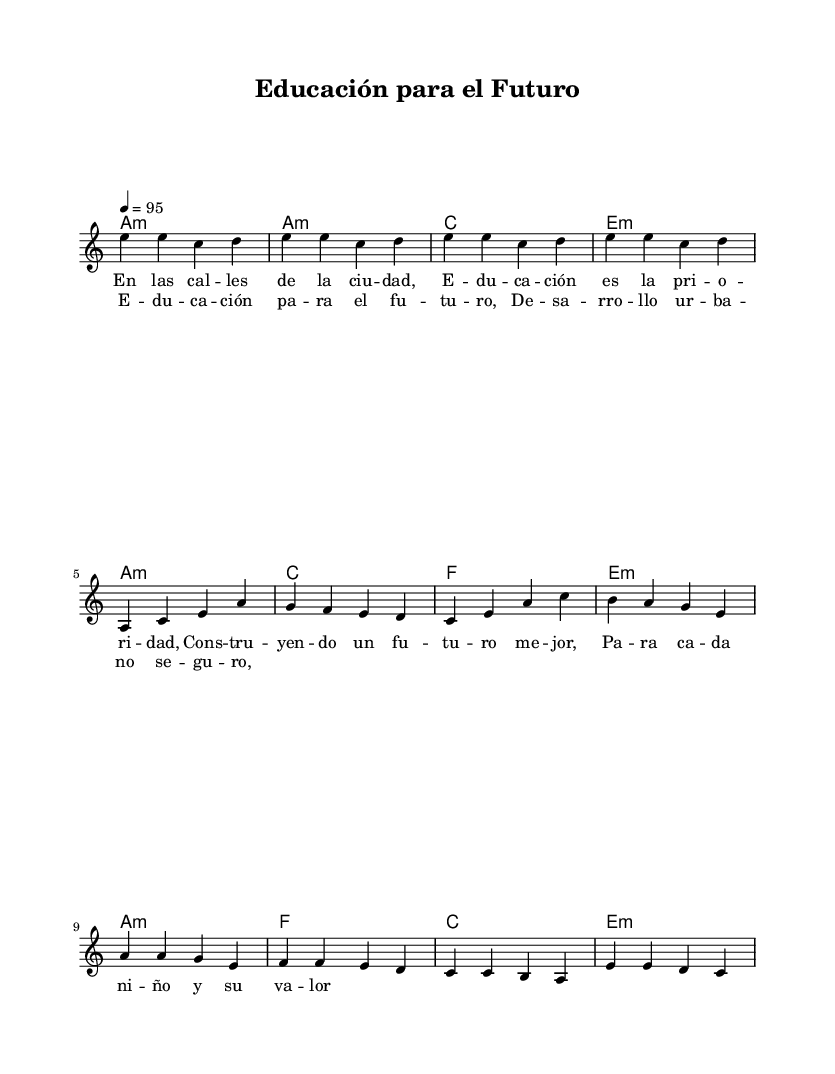What is the key signature of this music? The key signature is A minor, which has no sharps or flats indicated in the sheet music.
Answer: A minor What is the time signature of this music? The time signature is 4/4, which can be identified from the notation that indicates four beats per measure.
Answer: 4/4 What is the tempo marking for this piece? The tempo marking is 95 beats per minute, indicated by the "4 = 95" notation at the beginning.
Answer: 95 How many measures are in the chorus section? The chorus section consists of four measures, as counted from the notation provided for the chorus lyrics.
Answer: 4 What chords are used in the verse section? The chords in the verse section are A minor, C major, F major, and E minor, which are indicated in the chord mode section.
Answer: A minor, C major, F major, E minor What is the main theme of the lyrics in this piece? The main theme of the lyrics revolves around the importance of education and urban development, with a focus on building a better future for children.
Answer: Education and urban development How does the chorus contrast with the verse in musical structure? The chorus features a simpler melodic line combined with a repetition of chord patterns, creating a difference in intensity and emphasis compared to the more complex verse.
Answer: Simpler and repetitive 